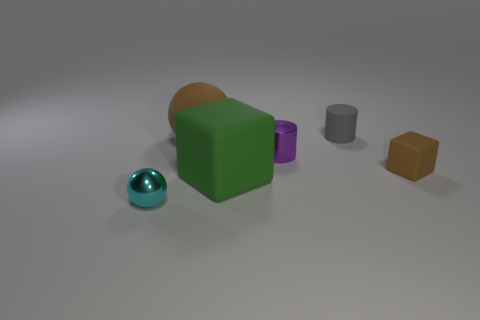Add 4 tiny red metal spheres. How many objects exist? 10 Subtract all big green matte objects. Subtract all small brown objects. How many objects are left? 4 Add 6 small brown things. How many small brown things are left? 7 Add 3 green matte objects. How many green matte objects exist? 4 Subtract 0 yellow spheres. How many objects are left? 6 